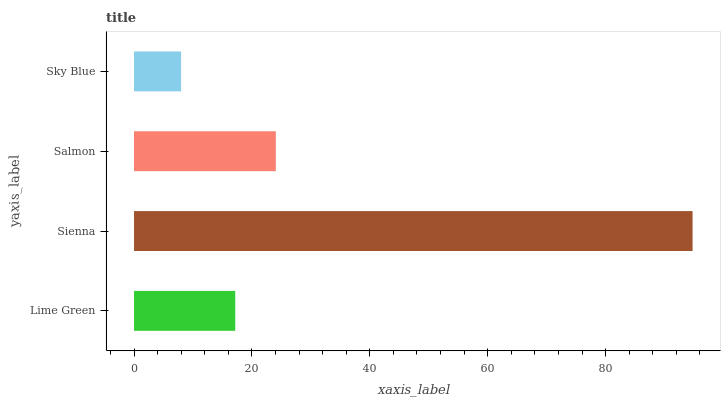Is Sky Blue the minimum?
Answer yes or no. Yes. Is Sienna the maximum?
Answer yes or no. Yes. Is Salmon the minimum?
Answer yes or no. No. Is Salmon the maximum?
Answer yes or no. No. Is Sienna greater than Salmon?
Answer yes or no. Yes. Is Salmon less than Sienna?
Answer yes or no. Yes. Is Salmon greater than Sienna?
Answer yes or no. No. Is Sienna less than Salmon?
Answer yes or no. No. Is Salmon the high median?
Answer yes or no. Yes. Is Lime Green the low median?
Answer yes or no. Yes. Is Lime Green the high median?
Answer yes or no. No. Is Salmon the low median?
Answer yes or no. No. 